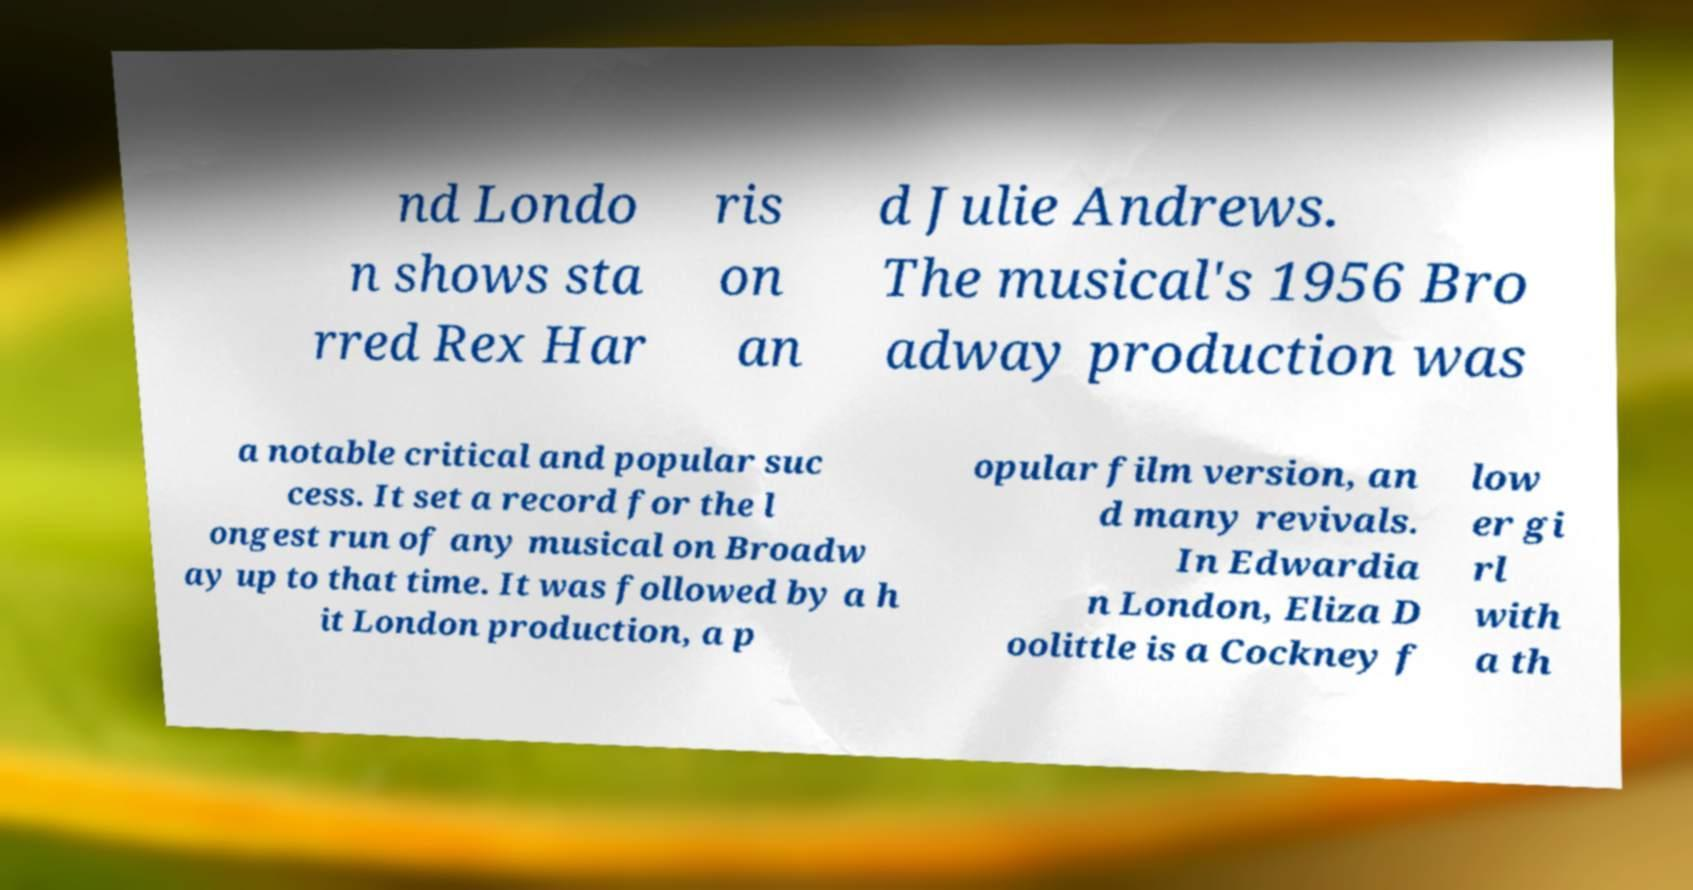I need the written content from this picture converted into text. Can you do that? nd Londo n shows sta rred Rex Har ris on an d Julie Andrews. The musical's 1956 Bro adway production was a notable critical and popular suc cess. It set a record for the l ongest run of any musical on Broadw ay up to that time. It was followed by a h it London production, a p opular film version, an d many revivals. In Edwardia n London, Eliza D oolittle is a Cockney f low er gi rl with a th 